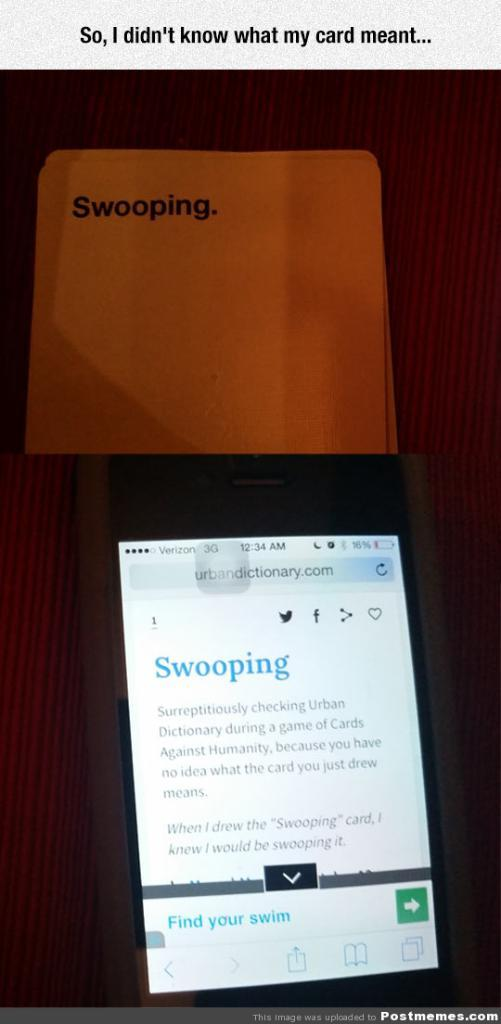Provide a one-sentence caption for the provided image. a phone lying on a table with swooping on the screen. 